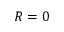Convert formula to latex. <formula><loc_0><loc_0><loc_500><loc_500>R = 0</formula> 